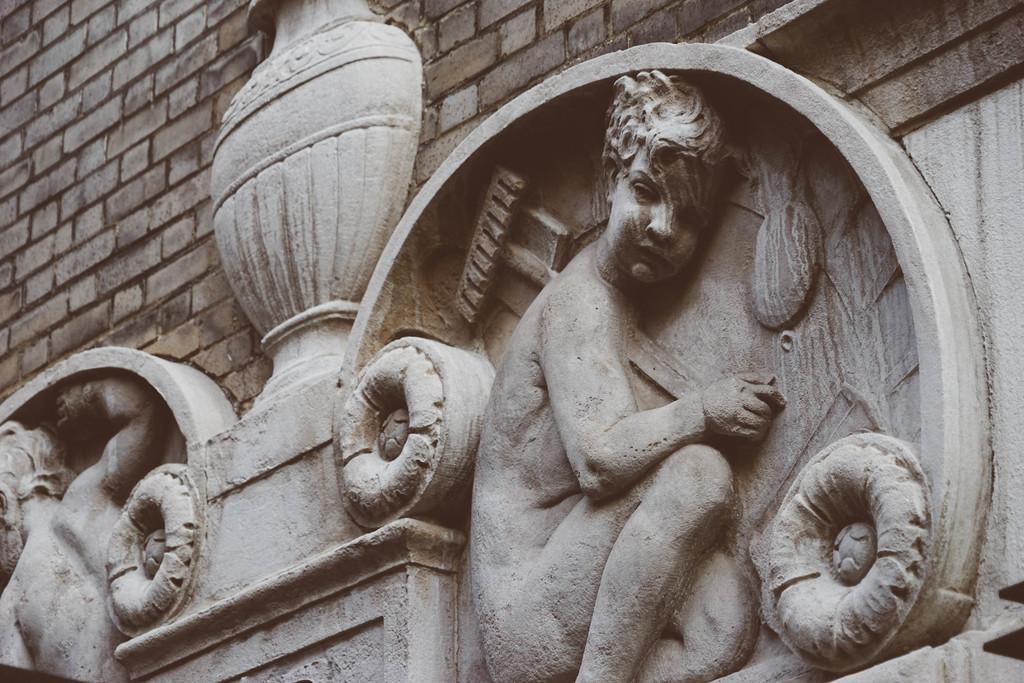In one or two sentences, can you explain what this image depicts? In this image there are two depictions are attached on the wall as we can see in the bottom of this image and there is a wall in the background. 